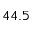<formula> <loc_0><loc_0><loc_500><loc_500>4 4 . 5</formula> 